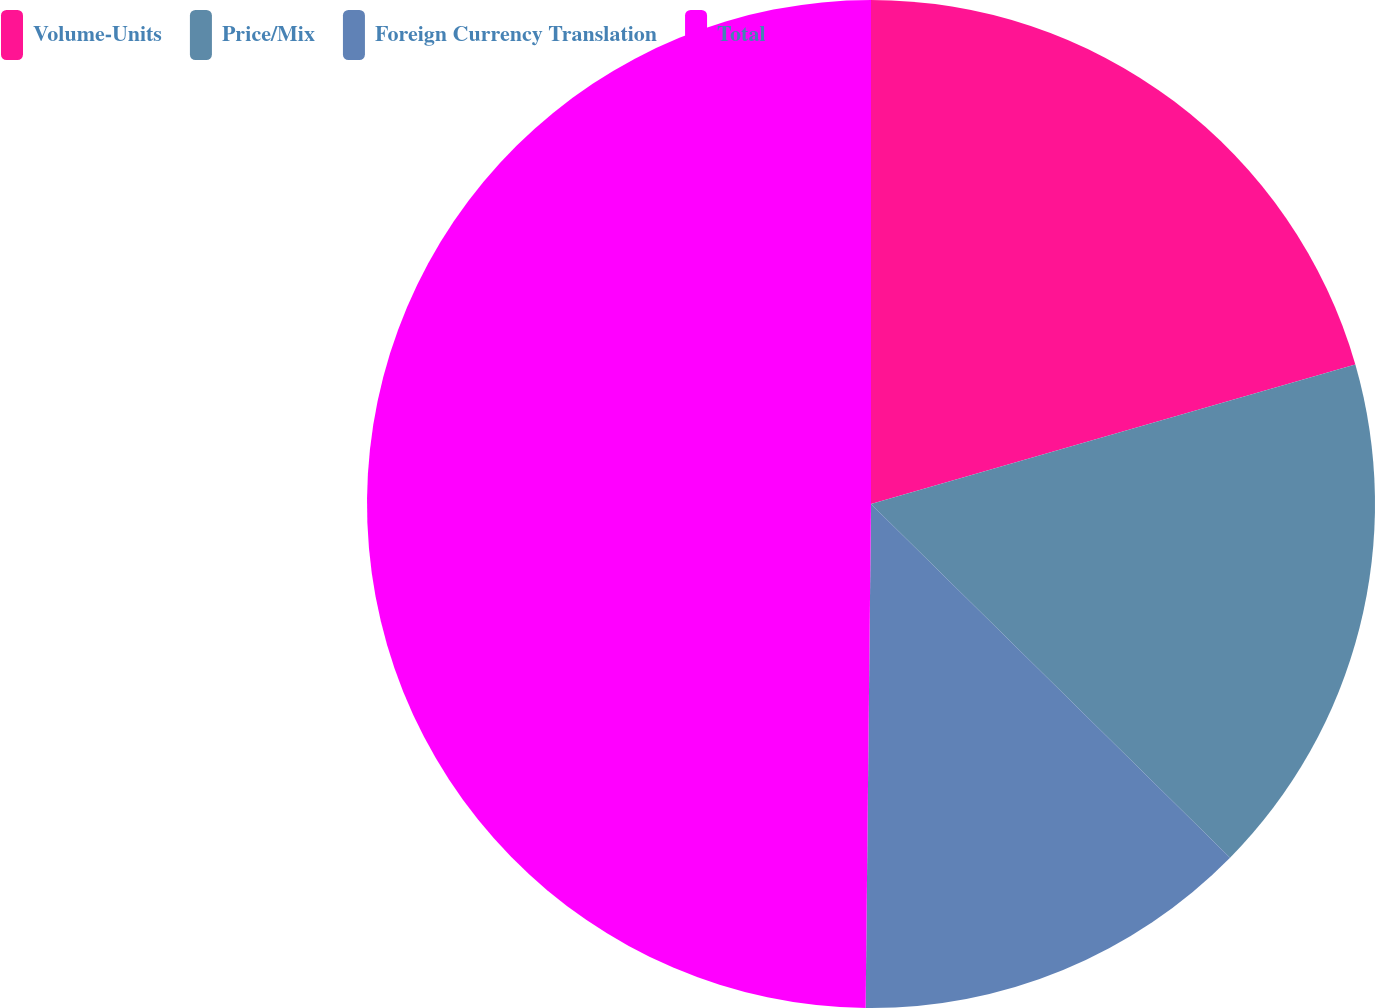Convert chart to OTSL. <chart><loc_0><loc_0><loc_500><loc_500><pie_chart><fcel>Volume-Units<fcel>Price/Mix<fcel>Foreign Currency Translation<fcel>Total<nl><fcel>20.54%<fcel>16.84%<fcel>12.79%<fcel>49.83%<nl></chart> 